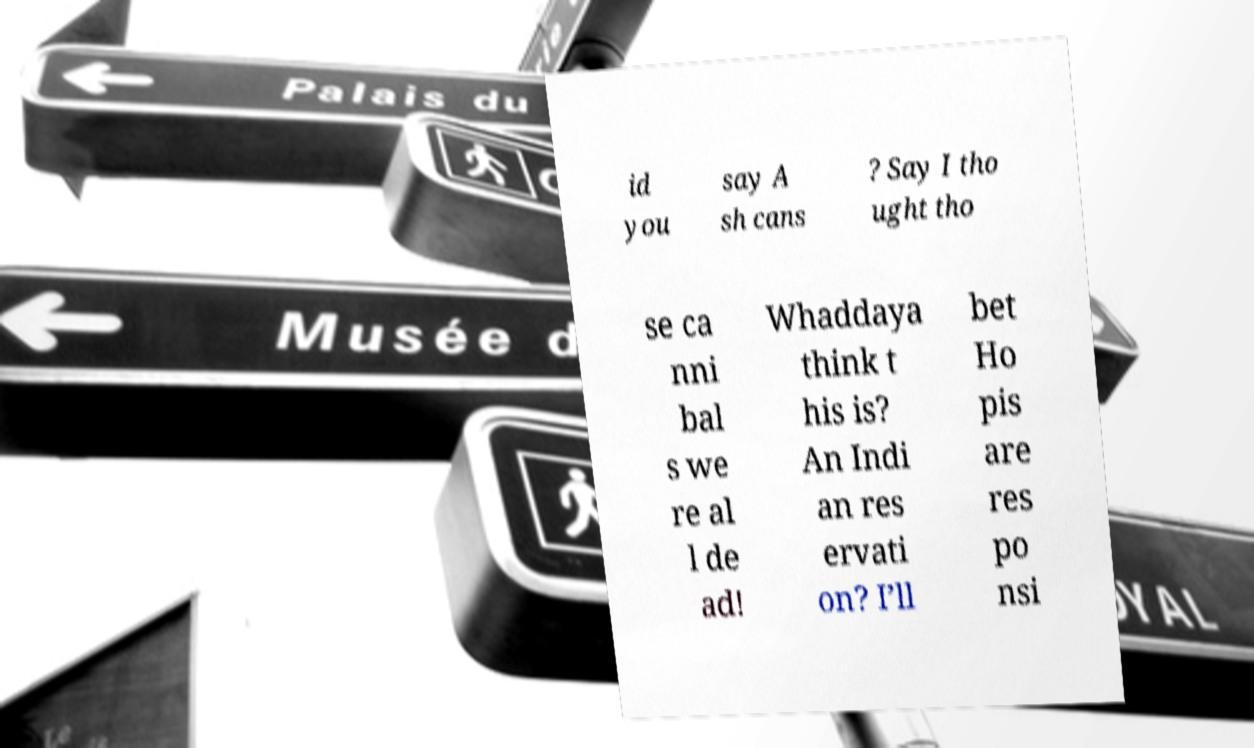There's text embedded in this image that I need extracted. Can you transcribe it verbatim? id you say A sh cans ? Say I tho ught tho se ca nni bal s we re al l de ad! Whaddaya think t his is? An Indi an res ervati on? I’ll bet Ho pis are res po nsi 